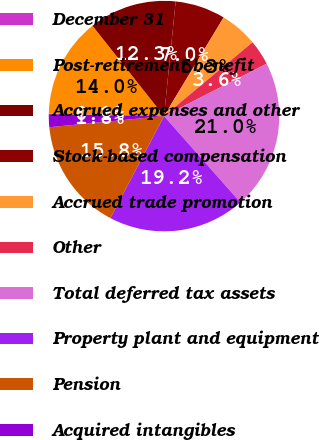Convert chart. <chart><loc_0><loc_0><loc_500><loc_500><pie_chart><fcel>December 31<fcel>Post-retirement benefit<fcel>Accrued expenses and other<fcel>Stock-based compensation<fcel>Accrued trade promotion<fcel>Other<fcel>Total deferred tax assets<fcel>Property plant and equipment<fcel>Pension<fcel>Acquired intangibles<nl><fcel>0.06%<fcel>14.01%<fcel>12.27%<fcel>7.04%<fcel>5.29%<fcel>3.55%<fcel>20.98%<fcel>19.24%<fcel>15.75%<fcel>1.81%<nl></chart> 